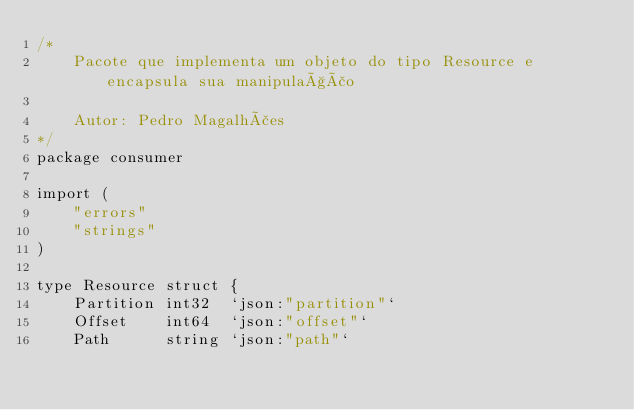<code> <loc_0><loc_0><loc_500><loc_500><_Go_>/*
	Pacote que implementa um objeto do tipo Resource e encapsula sua manipulação

	Autor: Pedro Magalhães
*/
package consumer

import (
	"errors"
	"strings"
)

type Resource struct {
	Partition int32  `json:"partition"`
	Offset    int64  `json:"offset"`
	Path      string `json:"path"`</code> 